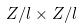Convert formula to latex. <formula><loc_0><loc_0><loc_500><loc_500>Z / l \times Z / l</formula> 